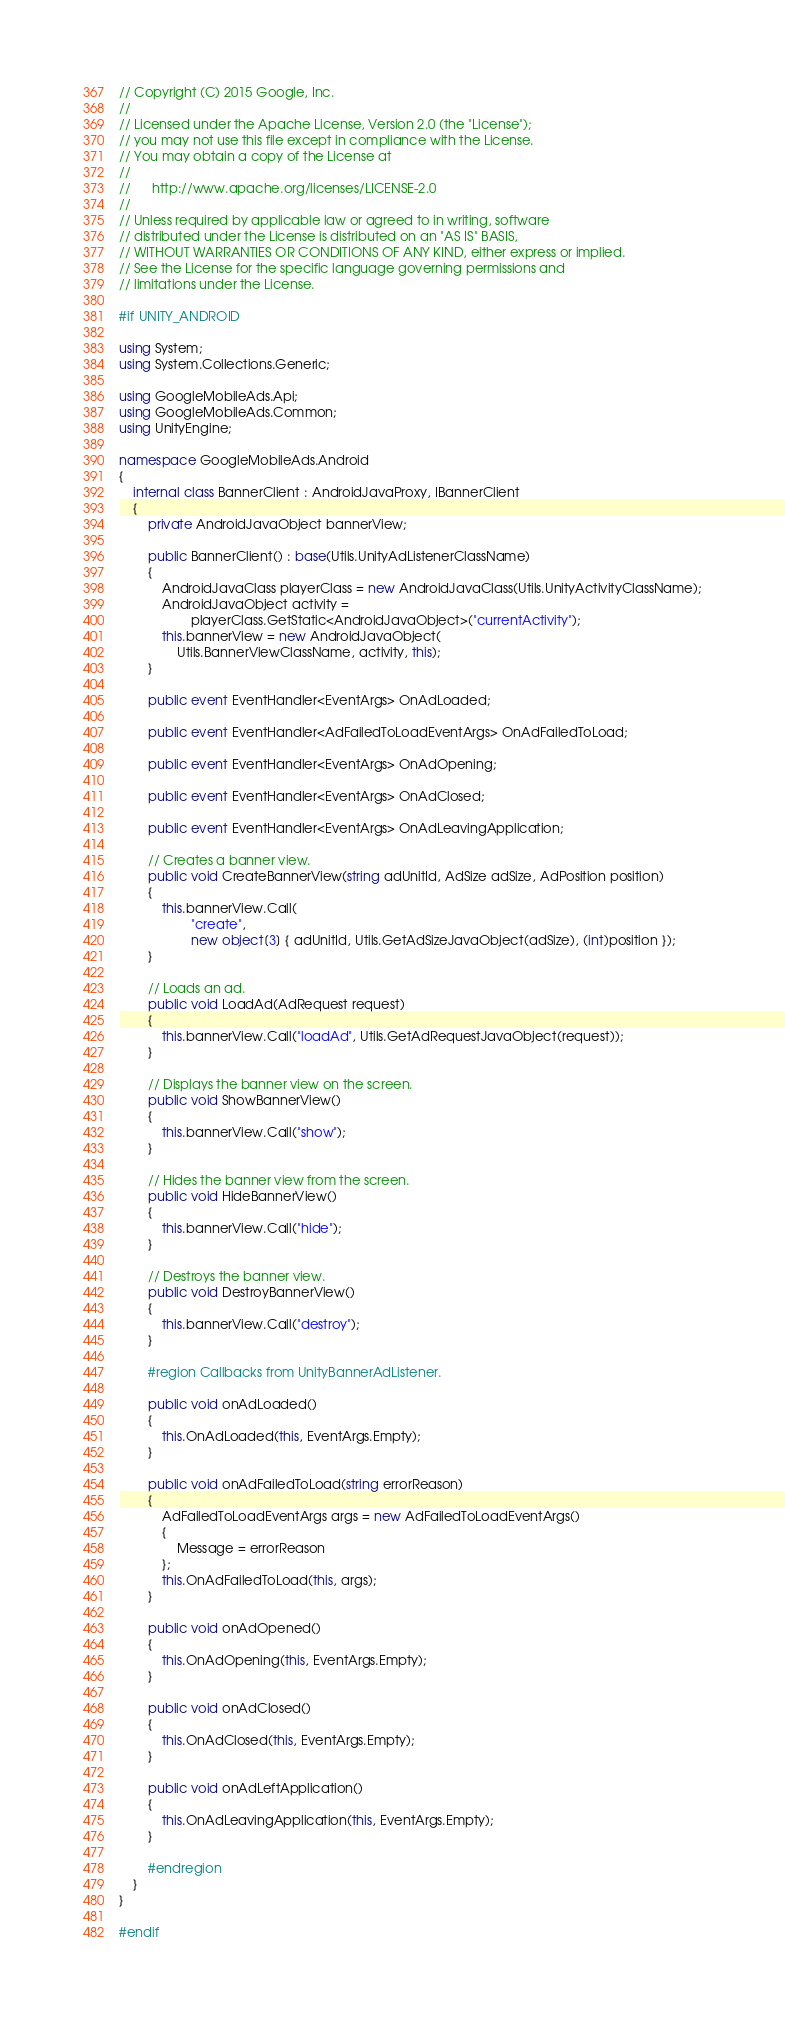Convert code to text. <code><loc_0><loc_0><loc_500><loc_500><_C#_>// Copyright (C) 2015 Google, Inc.
//
// Licensed under the Apache License, Version 2.0 (the "License");
// you may not use this file except in compliance with the License.
// You may obtain a copy of the License at
//
//      http://www.apache.org/licenses/LICENSE-2.0
//
// Unless required by applicable law or agreed to in writing, software
// distributed under the License is distributed on an "AS IS" BASIS,
// WITHOUT WARRANTIES OR CONDITIONS OF ANY KIND, either express or implied.
// See the License for the specific language governing permissions and
// limitations under the License.

#if UNITY_ANDROID

using System;
using System.Collections.Generic;

using GoogleMobileAds.Api;
using GoogleMobileAds.Common;
using UnityEngine;

namespace GoogleMobileAds.Android
{
    internal class BannerClient : AndroidJavaProxy, IBannerClient
    {
        private AndroidJavaObject bannerView;

        public BannerClient() : base(Utils.UnityAdListenerClassName)
        {
            AndroidJavaClass playerClass = new AndroidJavaClass(Utils.UnityActivityClassName);
            AndroidJavaObject activity =
                    playerClass.GetStatic<AndroidJavaObject>("currentActivity");
            this.bannerView = new AndroidJavaObject(
                Utils.BannerViewClassName, activity, this);
        }

        public event EventHandler<EventArgs> OnAdLoaded;

        public event EventHandler<AdFailedToLoadEventArgs> OnAdFailedToLoad;

        public event EventHandler<EventArgs> OnAdOpening;

        public event EventHandler<EventArgs> OnAdClosed;

        public event EventHandler<EventArgs> OnAdLeavingApplication;

        // Creates a banner view.
        public void CreateBannerView(string adUnitId, AdSize adSize, AdPosition position)
        {
            this.bannerView.Call(
                    "create",
                    new object[3] { adUnitId, Utils.GetAdSizeJavaObject(adSize), (int)position });
        }

        // Loads an ad.
        public void LoadAd(AdRequest request)
        {
            this.bannerView.Call("loadAd", Utils.GetAdRequestJavaObject(request));
        }

        // Displays the banner view on the screen.
        public void ShowBannerView()
        {
            this.bannerView.Call("show");
        }

        // Hides the banner view from the screen.
        public void HideBannerView()
        {
            this.bannerView.Call("hide");
        }

        // Destroys the banner view.
        public void DestroyBannerView()
        {
            this.bannerView.Call("destroy");
        }

        #region Callbacks from UnityBannerAdListener.

        public void onAdLoaded()
        {
            this.OnAdLoaded(this, EventArgs.Empty);
        }

        public void onAdFailedToLoad(string errorReason)
        {
            AdFailedToLoadEventArgs args = new AdFailedToLoadEventArgs()
            {
                Message = errorReason
            };
            this.OnAdFailedToLoad(this, args);
        }

        public void onAdOpened()
        {
            this.OnAdOpening(this, EventArgs.Empty);
        }

        public void onAdClosed()
        {
            this.OnAdClosed(this, EventArgs.Empty);
        }

        public void onAdLeftApplication()
        {
            this.OnAdLeavingApplication(this, EventArgs.Empty);
        }

        #endregion
    }
}

#endif
</code> 